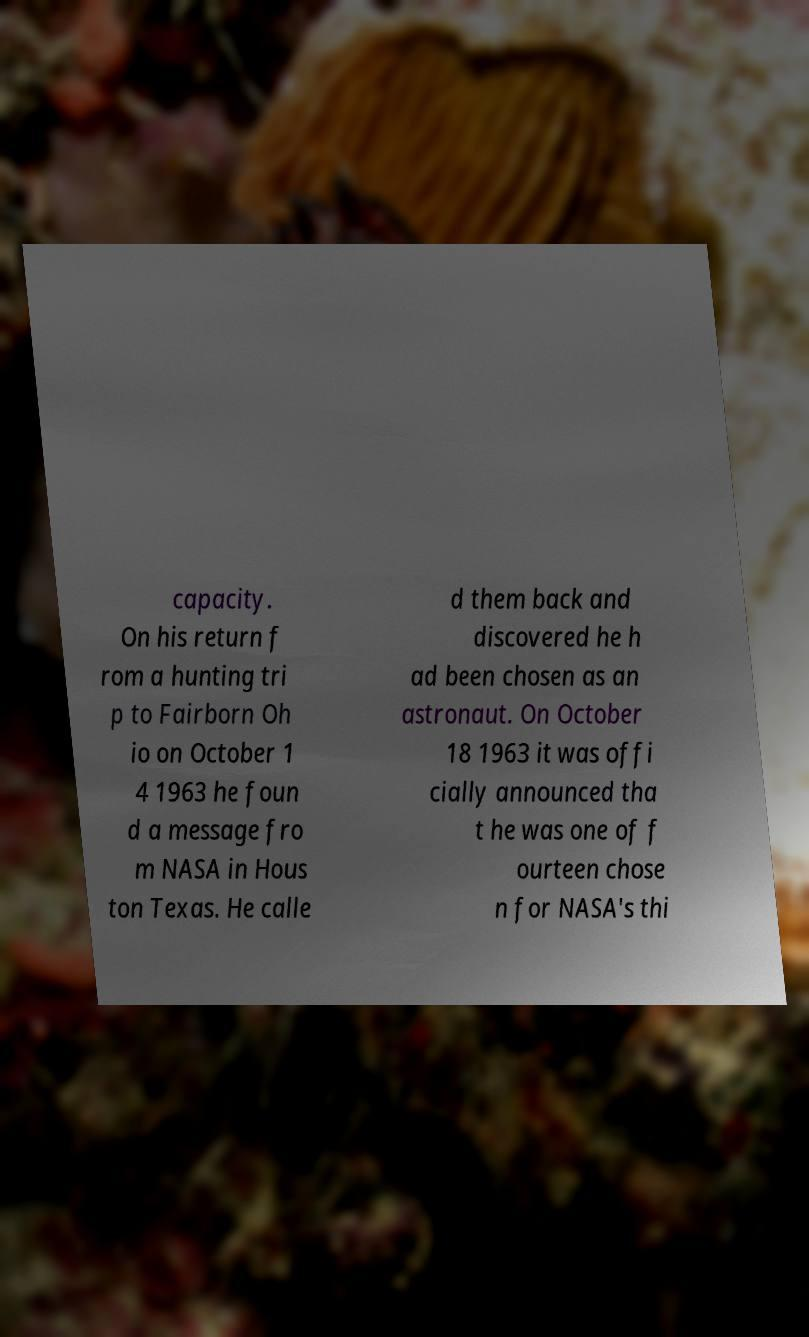Can you read and provide the text displayed in the image?This photo seems to have some interesting text. Can you extract and type it out for me? capacity. On his return f rom a hunting tri p to Fairborn Oh io on October 1 4 1963 he foun d a message fro m NASA in Hous ton Texas. He calle d them back and discovered he h ad been chosen as an astronaut. On October 18 1963 it was offi cially announced tha t he was one of f ourteen chose n for NASA's thi 